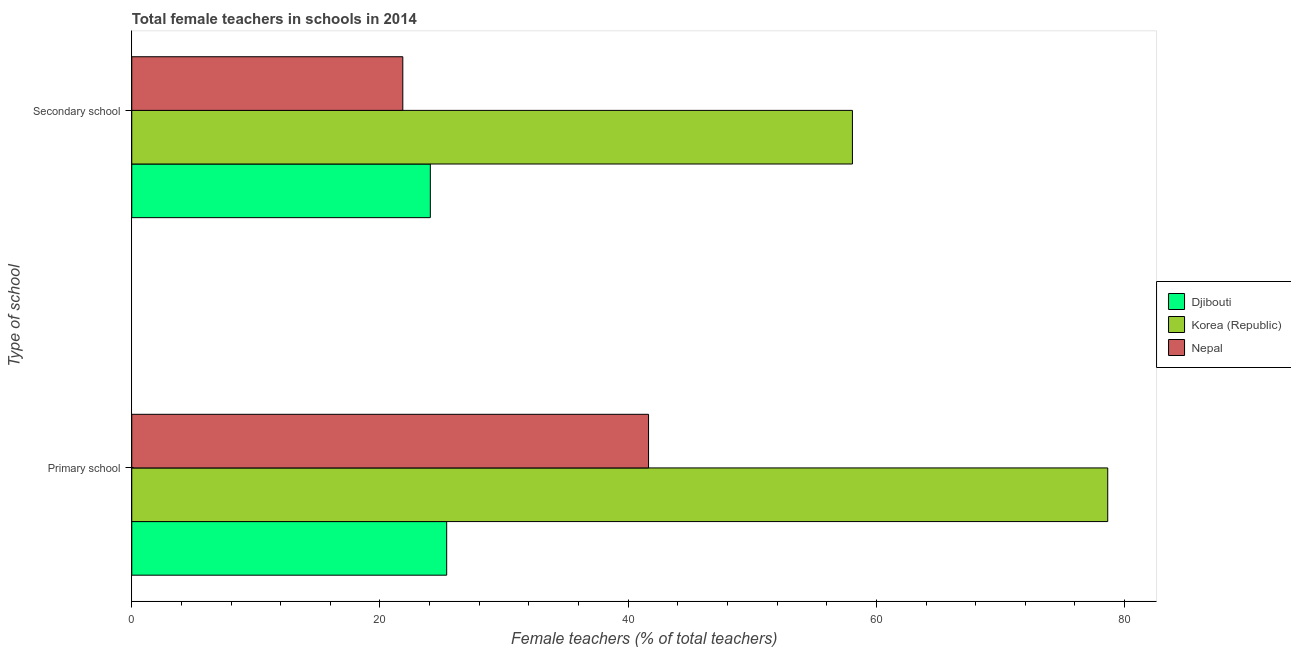How many different coloured bars are there?
Offer a terse response. 3. How many groups of bars are there?
Offer a very short reply. 2. Are the number of bars per tick equal to the number of legend labels?
Keep it short and to the point. Yes. What is the label of the 1st group of bars from the top?
Keep it short and to the point. Secondary school. What is the percentage of female teachers in primary schools in Korea (Republic)?
Offer a very short reply. 78.64. Across all countries, what is the maximum percentage of female teachers in secondary schools?
Provide a succinct answer. 58.07. Across all countries, what is the minimum percentage of female teachers in primary schools?
Give a very brief answer. 25.37. In which country was the percentage of female teachers in secondary schools minimum?
Make the answer very short. Nepal. What is the total percentage of female teachers in secondary schools in the graph?
Your answer should be very brief. 103.96. What is the difference between the percentage of female teachers in primary schools in Korea (Republic) and that in Nepal?
Your answer should be very brief. 37. What is the difference between the percentage of female teachers in secondary schools in Djibouti and the percentage of female teachers in primary schools in Korea (Republic)?
Your answer should be compact. -54.58. What is the average percentage of female teachers in secondary schools per country?
Give a very brief answer. 34.65. What is the difference between the percentage of female teachers in primary schools and percentage of female teachers in secondary schools in Djibouti?
Give a very brief answer. 1.32. What is the ratio of the percentage of female teachers in primary schools in Korea (Republic) to that in Nepal?
Make the answer very short. 1.89. Is the percentage of female teachers in secondary schools in Djibouti less than that in Nepal?
Give a very brief answer. No. In how many countries, is the percentage of female teachers in secondary schools greater than the average percentage of female teachers in secondary schools taken over all countries?
Your answer should be very brief. 1. What does the 1st bar from the top in Secondary school represents?
Your answer should be very brief. Nepal. What does the 3rd bar from the bottom in Secondary school represents?
Your answer should be very brief. Nepal. Are all the bars in the graph horizontal?
Ensure brevity in your answer.  Yes. What is the difference between two consecutive major ticks on the X-axis?
Give a very brief answer. 20. Are the values on the major ticks of X-axis written in scientific E-notation?
Provide a succinct answer. No. Does the graph contain any zero values?
Ensure brevity in your answer.  No. Does the graph contain grids?
Offer a terse response. No. Where does the legend appear in the graph?
Your answer should be very brief. Center right. How many legend labels are there?
Your answer should be compact. 3. How are the legend labels stacked?
Offer a very short reply. Vertical. What is the title of the graph?
Offer a very short reply. Total female teachers in schools in 2014. What is the label or title of the X-axis?
Provide a succinct answer. Female teachers (% of total teachers). What is the label or title of the Y-axis?
Ensure brevity in your answer.  Type of school. What is the Female teachers (% of total teachers) of Djibouti in Primary school?
Provide a succinct answer. 25.37. What is the Female teachers (% of total teachers) in Korea (Republic) in Primary school?
Your answer should be compact. 78.64. What is the Female teachers (% of total teachers) in Nepal in Primary school?
Provide a short and direct response. 41.64. What is the Female teachers (% of total teachers) of Djibouti in Secondary school?
Ensure brevity in your answer.  24.06. What is the Female teachers (% of total teachers) in Korea (Republic) in Secondary school?
Make the answer very short. 58.07. What is the Female teachers (% of total teachers) of Nepal in Secondary school?
Your response must be concise. 21.84. Across all Type of school, what is the maximum Female teachers (% of total teachers) of Djibouti?
Keep it short and to the point. 25.37. Across all Type of school, what is the maximum Female teachers (% of total teachers) of Korea (Republic)?
Give a very brief answer. 78.64. Across all Type of school, what is the maximum Female teachers (% of total teachers) of Nepal?
Provide a short and direct response. 41.64. Across all Type of school, what is the minimum Female teachers (% of total teachers) in Djibouti?
Offer a very short reply. 24.06. Across all Type of school, what is the minimum Female teachers (% of total teachers) in Korea (Republic)?
Your answer should be compact. 58.07. Across all Type of school, what is the minimum Female teachers (% of total teachers) in Nepal?
Keep it short and to the point. 21.84. What is the total Female teachers (% of total teachers) of Djibouti in the graph?
Offer a very short reply. 49.43. What is the total Female teachers (% of total teachers) of Korea (Republic) in the graph?
Your answer should be compact. 136.71. What is the total Female teachers (% of total teachers) of Nepal in the graph?
Your answer should be compact. 63.48. What is the difference between the Female teachers (% of total teachers) in Djibouti in Primary school and that in Secondary school?
Offer a terse response. 1.32. What is the difference between the Female teachers (% of total teachers) in Korea (Republic) in Primary school and that in Secondary school?
Keep it short and to the point. 20.57. What is the difference between the Female teachers (% of total teachers) in Nepal in Primary school and that in Secondary school?
Keep it short and to the point. 19.8. What is the difference between the Female teachers (% of total teachers) of Djibouti in Primary school and the Female teachers (% of total teachers) of Korea (Republic) in Secondary school?
Ensure brevity in your answer.  -32.69. What is the difference between the Female teachers (% of total teachers) in Djibouti in Primary school and the Female teachers (% of total teachers) in Nepal in Secondary school?
Provide a succinct answer. 3.54. What is the difference between the Female teachers (% of total teachers) in Korea (Republic) in Primary school and the Female teachers (% of total teachers) in Nepal in Secondary school?
Your response must be concise. 56.8. What is the average Female teachers (% of total teachers) of Djibouti per Type of school?
Your answer should be very brief. 24.72. What is the average Female teachers (% of total teachers) in Korea (Republic) per Type of school?
Offer a terse response. 68.35. What is the average Female teachers (% of total teachers) of Nepal per Type of school?
Ensure brevity in your answer.  31.74. What is the difference between the Female teachers (% of total teachers) in Djibouti and Female teachers (% of total teachers) in Korea (Republic) in Primary school?
Provide a short and direct response. -53.26. What is the difference between the Female teachers (% of total teachers) in Djibouti and Female teachers (% of total teachers) in Nepal in Primary school?
Your answer should be very brief. -16.27. What is the difference between the Female teachers (% of total teachers) of Korea (Republic) and Female teachers (% of total teachers) of Nepal in Primary school?
Ensure brevity in your answer.  37. What is the difference between the Female teachers (% of total teachers) of Djibouti and Female teachers (% of total teachers) of Korea (Republic) in Secondary school?
Your answer should be very brief. -34.01. What is the difference between the Female teachers (% of total teachers) in Djibouti and Female teachers (% of total teachers) in Nepal in Secondary school?
Your answer should be compact. 2.22. What is the difference between the Female teachers (% of total teachers) of Korea (Republic) and Female teachers (% of total teachers) of Nepal in Secondary school?
Provide a succinct answer. 36.23. What is the ratio of the Female teachers (% of total teachers) of Djibouti in Primary school to that in Secondary school?
Give a very brief answer. 1.05. What is the ratio of the Female teachers (% of total teachers) in Korea (Republic) in Primary school to that in Secondary school?
Offer a very short reply. 1.35. What is the ratio of the Female teachers (% of total teachers) of Nepal in Primary school to that in Secondary school?
Give a very brief answer. 1.91. What is the difference between the highest and the second highest Female teachers (% of total teachers) of Djibouti?
Keep it short and to the point. 1.32. What is the difference between the highest and the second highest Female teachers (% of total teachers) in Korea (Republic)?
Your response must be concise. 20.57. What is the difference between the highest and the second highest Female teachers (% of total teachers) of Nepal?
Offer a very short reply. 19.8. What is the difference between the highest and the lowest Female teachers (% of total teachers) of Djibouti?
Provide a short and direct response. 1.32. What is the difference between the highest and the lowest Female teachers (% of total teachers) in Korea (Republic)?
Provide a succinct answer. 20.57. What is the difference between the highest and the lowest Female teachers (% of total teachers) of Nepal?
Offer a very short reply. 19.8. 